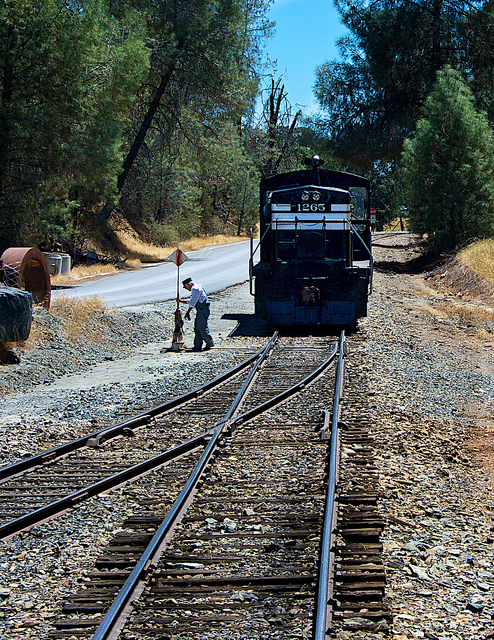How many people are visible? There is 1 person visible in the image, standing on the tracks in front of the locomotive, seemingly involved in some type of rail maintenance or inspection activity. 